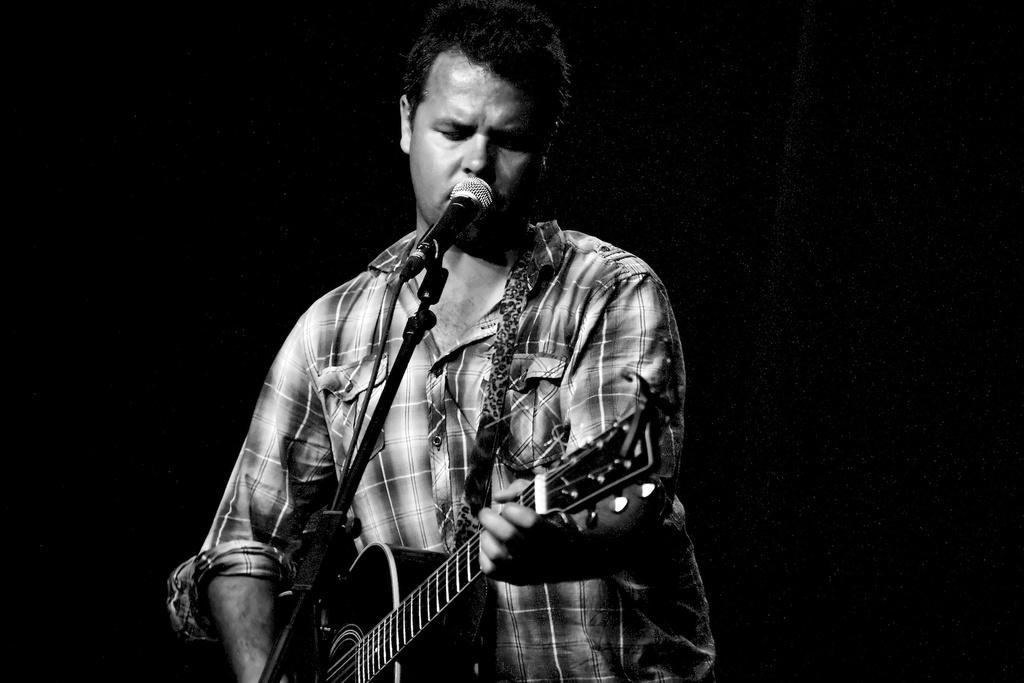Please provide a concise description of this image. This is completely a black & white picture. in this picture we can see a man standing in front of a mike and playing guitar. 